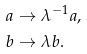Convert formula to latex. <formula><loc_0><loc_0><loc_500><loc_500>& a \to \lambda ^ { - 1 } a , \\ & b \to \lambda b .</formula> 